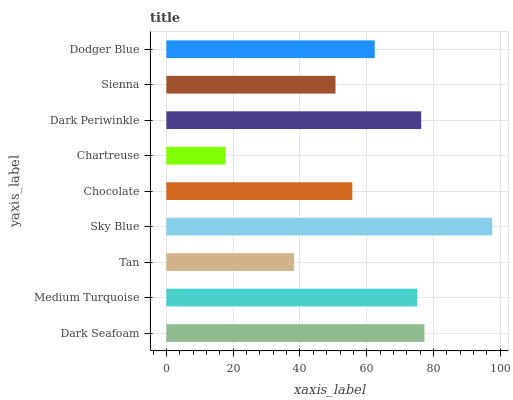Is Chartreuse the minimum?
Answer yes or no. Yes. Is Sky Blue the maximum?
Answer yes or no. Yes. Is Medium Turquoise the minimum?
Answer yes or no. No. Is Medium Turquoise the maximum?
Answer yes or no. No. Is Dark Seafoam greater than Medium Turquoise?
Answer yes or no. Yes. Is Medium Turquoise less than Dark Seafoam?
Answer yes or no. Yes. Is Medium Turquoise greater than Dark Seafoam?
Answer yes or no. No. Is Dark Seafoam less than Medium Turquoise?
Answer yes or no. No. Is Dodger Blue the high median?
Answer yes or no. Yes. Is Dodger Blue the low median?
Answer yes or no. Yes. Is Chartreuse the high median?
Answer yes or no. No. Is Dark Periwinkle the low median?
Answer yes or no. No. 